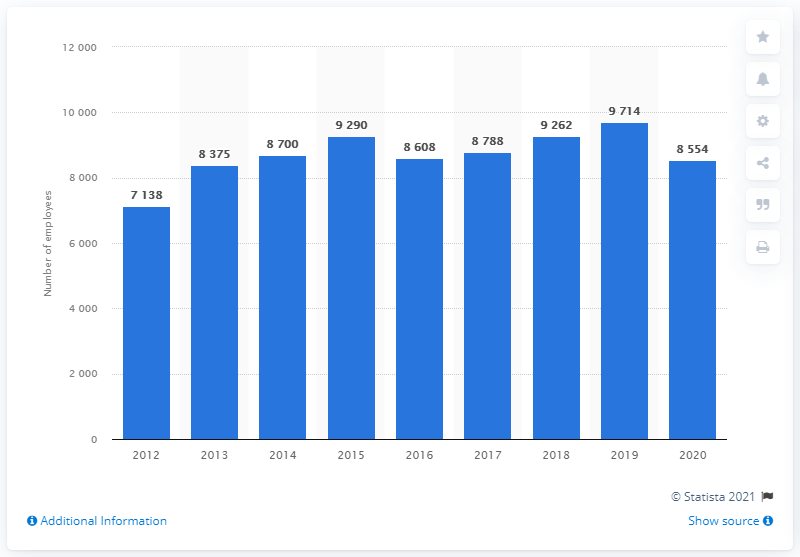Outline some significant characteristics in this image. In the year 2016, Regus changed its name to IWG. 